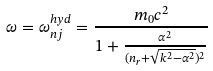<formula> <loc_0><loc_0><loc_500><loc_500>\omega = \omega _ { n j } ^ { h y d } = \frac { m _ { 0 } c ^ { 2 } } { { 1 + \frac { \alpha ^ { 2 } } { ( n _ { r } + \sqrt { k ^ { 2 } - \alpha ^ { 2 } } ) ^ { 2 } } } }</formula> 